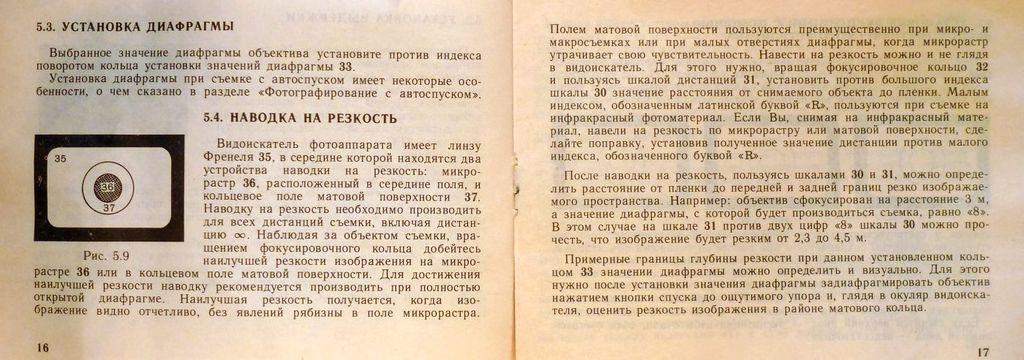Could you give a brief overview of what you see in this image? In this picture we can see two papers here, we can see some text on these papers, we can also see page numbers here. 